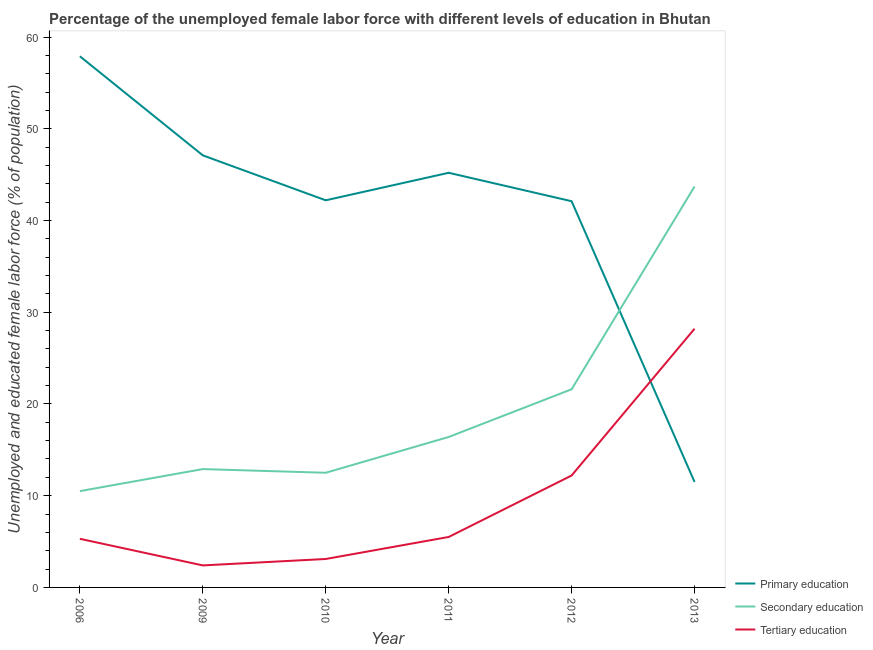Does the line corresponding to percentage of female labor force who received tertiary education intersect with the line corresponding to percentage of female labor force who received primary education?
Provide a short and direct response. Yes. Across all years, what is the maximum percentage of female labor force who received primary education?
Your response must be concise. 57.9. What is the total percentage of female labor force who received primary education in the graph?
Give a very brief answer. 246. What is the difference between the percentage of female labor force who received primary education in 2013 and the percentage of female labor force who received tertiary education in 2011?
Give a very brief answer. 6. What is the average percentage of female labor force who received primary education per year?
Provide a short and direct response. 41. In the year 2012, what is the difference between the percentage of female labor force who received tertiary education and percentage of female labor force who received secondary education?
Make the answer very short. -9.4. In how many years, is the percentage of female labor force who received tertiary education greater than 16 %?
Ensure brevity in your answer.  1. What is the ratio of the percentage of female labor force who received tertiary education in 2010 to that in 2012?
Your answer should be compact. 0.25. What is the difference between the highest and the second highest percentage of female labor force who received tertiary education?
Provide a succinct answer. 16. What is the difference between the highest and the lowest percentage of female labor force who received secondary education?
Give a very brief answer. 33.2. Is the sum of the percentage of female labor force who received tertiary education in 2006 and 2010 greater than the maximum percentage of female labor force who received primary education across all years?
Offer a terse response. No. Does the percentage of female labor force who received primary education monotonically increase over the years?
Provide a short and direct response. No. Is the percentage of female labor force who received primary education strictly greater than the percentage of female labor force who received tertiary education over the years?
Your response must be concise. No. Is the percentage of female labor force who received secondary education strictly less than the percentage of female labor force who received tertiary education over the years?
Make the answer very short. No. How many lines are there?
Keep it short and to the point. 3. How many years are there in the graph?
Your answer should be very brief. 6. Does the graph contain any zero values?
Your answer should be very brief. No. What is the title of the graph?
Your answer should be very brief. Percentage of the unemployed female labor force with different levels of education in Bhutan. What is the label or title of the Y-axis?
Your response must be concise. Unemployed and educated female labor force (% of population). What is the Unemployed and educated female labor force (% of population) of Primary education in 2006?
Your answer should be compact. 57.9. What is the Unemployed and educated female labor force (% of population) of Secondary education in 2006?
Provide a succinct answer. 10.5. What is the Unemployed and educated female labor force (% of population) in Tertiary education in 2006?
Provide a succinct answer. 5.3. What is the Unemployed and educated female labor force (% of population) in Primary education in 2009?
Provide a succinct answer. 47.1. What is the Unemployed and educated female labor force (% of population) of Secondary education in 2009?
Ensure brevity in your answer.  12.9. What is the Unemployed and educated female labor force (% of population) of Tertiary education in 2009?
Give a very brief answer. 2.4. What is the Unemployed and educated female labor force (% of population) of Primary education in 2010?
Make the answer very short. 42.2. What is the Unemployed and educated female labor force (% of population) of Tertiary education in 2010?
Provide a short and direct response. 3.1. What is the Unemployed and educated female labor force (% of population) of Primary education in 2011?
Provide a short and direct response. 45.2. What is the Unemployed and educated female labor force (% of population) of Secondary education in 2011?
Your answer should be very brief. 16.4. What is the Unemployed and educated female labor force (% of population) of Tertiary education in 2011?
Give a very brief answer. 5.5. What is the Unemployed and educated female labor force (% of population) in Primary education in 2012?
Offer a terse response. 42.1. What is the Unemployed and educated female labor force (% of population) of Secondary education in 2012?
Ensure brevity in your answer.  21.6. What is the Unemployed and educated female labor force (% of population) in Tertiary education in 2012?
Provide a short and direct response. 12.2. What is the Unemployed and educated female labor force (% of population) in Primary education in 2013?
Provide a short and direct response. 11.5. What is the Unemployed and educated female labor force (% of population) of Secondary education in 2013?
Provide a succinct answer. 43.7. What is the Unemployed and educated female labor force (% of population) in Tertiary education in 2013?
Make the answer very short. 28.2. Across all years, what is the maximum Unemployed and educated female labor force (% of population) in Primary education?
Ensure brevity in your answer.  57.9. Across all years, what is the maximum Unemployed and educated female labor force (% of population) in Secondary education?
Provide a short and direct response. 43.7. Across all years, what is the maximum Unemployed and educated female labor force (% of population) of Tertiary education?
Offer a very short reply. 28.2. Across all years, what is the minimum Unemployed and educated female labor force (% of population) in Primary education?
Your answer should be compact. 11.5. Across all years, what is the minimum Unemployed and educated female labor force (% of population) of Secondary education?
Your answer should be compact. 10.5. Across all years, what is the minimum Unemployed and educated female labor force (% of population) of Tertiary education?
Offer a terse response. 2.4. What is the total Unemployed and educated female labor force (% of population) of Primary education in the graph?
Make the answer very short. 246. What is the total Unemployed and educated female labor force (% of population) in Secondary education in the graph?
Ensure brevity in your answer.  117.6. What is the total Unemployed and educated female labor force (% of population) in Tertiary education in the graph?
Give a very brief answer. 56.7. What is the difference between the Unemployed and educated female labor force (% of population) of Secondary education in 2006 and that in 2009?
Offer a very short reply. -2.4. What is the difference between the Unemployed and educated female labor force (% of population) in Secondary education in 2006 and that in 2010?
Your response must be concise. -2. What is the difference between the Unemployed and educated female labor force (% of population) of Tertiary education in 2006 and that in 2010?
Your response must be concise. 2.2. What is the difference between the Unemployed and educated female labor force (% of population) in Tertiary education in 2006 and that in 2011?
Keep it short and to the point. -0.2. What is the difference between the Unemployed and educated female labor force (% of population) in Primary education in 2006 and that in 2013?
Provide a short and direct response. 46.4. What is the difference between the Unemployed and educated female labor force (% of population) in Secondary education in 2006 and that in 2013?
Your response must be concise. -33.2. What is the difference between the Unemployed and educated female labor force (% of population) of Tertiary education in 2006 and that in 2013?
Keep it short and to the point. -22.9. What is the difference between the Unemployed and educated female labor force (% of population) in Primary education in 2009 and that in 2010?
Your response must be concise. 4.9. What is the difference between the Unemployed and educated female labor force (% of population) of Primary education in 2009 and that in 2011?
Give a very brief answer. 1.9. What is the difference between the Unemployed and educated female labor force (% of population) of Secondary education in 2009 and that in 2011?
Offer a terse response. -3.5. What is the difference between the Unemployed and educated female labor force (% of population) of Tertiary education in 2009 and that in 2011?
Provide a short and direct response. -3.1. What is the difference between the Unemployed and educated female labor force (% of population) of Primary education in 2009 and that in 2013?
Keep it short and to the point. 35.6. What is the difference between the Unemployed and educated female labor force (% of population) in Secondary education in 2009 and that in 2013?
Ensure brevity in your answer.  -30.8. What is the difference between the Unemployed and educated female labor force (% of population) in Tertiary education in 2009 and that in 2013?
Offer a terse response. -25.8. What is the difference between the Unemployed and educated female labor force (% of population) in Secondary education in 2010 and that in 2011?
Keep it short and to the point. -3.9. What is the difference between the Unemployed and educated female labor force (% of population) in Tertiary education in 2010 and that in 2011?
Your answer should be very brief. -2.4. What is the difference between the Unemployed and educated female labor force (% of population) of Tertiary education in 2010 and that in 2012?
Offer a very short reply. -9.1. What is the difference between the Unemployed and educated female labor force (% of population) in Primary education in 2010 and that in 2013?
Provide a short and direct response. 30.7. What is the difference between the Unemployed and educated female labor force (% of population) of Secondary education in 2010 and that in 2013?
Your answer should be compact. -31.2. What is the difference between the Unemployed and educated female labor force (% of population) of Tertiary education in 2010 and that in 2013?
Keep it short and to the point. -25.1. What is the difference between the Unemployed and educated female labor force (% of population) in Primary education in 2011 and that in 2012?
Your answer should be very brief. 3.1. What is the difference between the Unemployed and educated female labor force (% of population) of Tertiary education in 2011 and that in 2012?
Provide a succinct answer. -6.7. What is the difference between the Unemployed and educated female labor force (% of population) of Primary education in 2011 and that in 2013?
Your answer should be very brief. 33.7. What is the difference between the Unemployed and educated female labor force (% of population) of Secondary education in 2011 and that in 2013?
Provide a short and direct response. -27.3. What is the difference between the Unemployed and educated female labor force (% of population) of Tertiary education in 2011 and that in 2013?
Give a very brief answer. -22.7. What is the difference between the Unemployed and educated female labor force (% of population) in Primary education in 2012 and that in 2013?
Ensure brevity in your answer.  30.6. What is the difference between the Unemployed and educated female labor force (% of population) of Secondary education in 2012 and that in 2013?
Offer a terse response. -22.1. What is the difference between the Unemployed and educated female labor force (% of population) of Tertiary education in 2012 and that in 2013?
Your answer should be very brief. -16. What is the difference between the Unemployed and educated female labor force (% of population) in Primary education in 2006 and the Unemployed and educated female labor force (% of population) in Secondary education in 2009?
Your answer should be compact. 45. What is the difference between the Unemployed and educated female labor force (% of population) of Primary education in 2006 and the Unemployed and educated female labor force (% of population) of Tertiary education in 2009?
Offer a terse response. 55.5. What is the difference between the Unemployed and educated female labor force (% of population) in Secondary education in 2006 and the Unemployed and educated female labor force (% of population) in Tertiary education in 2009?
Offer a terse response. 8.1. What is the difference between the Unemployed and educated female labor force (% of population) in Primary education in 2006 and the Unemployed and educated female labor force (% of population) in Secondary education in 2010?
Keep it short and to the point. 45.4. What is the difference between the Unemployed and educated female labor force (% of population) of Primary education in 2006 and the Unemployed and educated female labor force (% of population) of Tertiary education in 2010?
Keep it short and to the point. 54.8. What is the difference between the Unemployed and educated female labor force (% of population) in Secondary education in 2006 and the Unemployed and educated female labor force (% of population) in Tertiary education in 2010?
Offer a very short reply. 7.4. What is the difference between the Unemployed and educated female labor force (% of population) in Primary education in 2006 and the Unemployed and educated female labor force (% of population) in Secondary education in 2011?
Keep it short and to the point. 41.5. What is the difference between the Unemployed and educated female labor force (% of population) in Primary education in 2006 and the Unemployed and educated female labor force (% of population) in Tertiary education in 2011?
Offer a very short reply. 52.4. What is the difference between the Unemployed and educated female labor force (% of population) in Secondary education in 2006 and the Unemployed and educated female labor force (% of population) in Tertiary education in 2011?
Make the answer very short. 5. What is the difference between the Unemployed and educated female labor force (% of population) in Primary education in 2006 and the Unemployed and educated female labor force (% of population) in Secondary education in 2012?
Keep it short and to the point. 36.3. What is the difference between the Unemployed and educated female labor force (% of population) of Primary education in 2006 and the Unemployed and educated female labor force (% of population) of Tertiary education in 2012?
Offer a terse response. 45.7. What is the difference between the Unemployed and educated female labor force (% of population) of Primary education in 2006 and the Unemployed and educated female labor force (% of population) of Secondary education in 2013?
Provide a succinct answer. 14.2. What is the difference between the Unemployed and educated female labor force (% of population) of Primary education in 2006 and the Unemployed and educated female labor force (% of population) of Tertiary education in 2013?
Give a very brief answer. 29.7. What is the difference between the Unemployed and educated female labor force (% of population) of Secondary education in 2006 and the Unemployed and educated female labor force (% of population) of Tertiary education in 2013?
Offer a terse response. -17.7. What is the difference between the Unemployed and educated female labor force (% of population) in Primary education in 2009 and the Unemployed and educated female labor force (% of population) in Secondary education in 2010?
Your answer should be compact. 34.6. What is the difference between the Unemployed and educated female labor force (% of population) in Secondary education in 2009 and the Unemployed and educated female labor force (% of population) in Tertiary education in 2010?
Give a very brief answer. 9.8. What is the difference between the Unemployed and educated female labor force (% of population) of Primary education in 2009 and the Unemployed and educated female labor force (% of population) of Secondary education in 2011?
Provide a succinct answer. 30.7. What is the difference between the Unemployed and educated female labor force (% of population) of Primary education in 2009 and the Unemployed and educated female labor force (% of population) of Tertiary education in 2011?
Make the answer very short. 41.6. What is the difference between the Unemployed and educated female labor force (% of population) in Primary education in 2009 and the Unemployed and educated female labor force (% of population) in Secondary education in 2012?
Provide a short and direct response. 25.5. What is the difference between the Unemployed and educated female labor force (% of population) in Primary education in 2009 and the Unemployed and educated female labor force (% of population) in Tertiary education in 2012?
Your answer should be compact. 34.9. What is the difference between the Unemployed and educated female labor force (% of population) of Secondary education in 2009 and the Unemployed and educated female labor force (% of population) of Tertiary education in 2012?
Keep it short and to the point. 0.7. What is the difference between the Unemployed and educated female labor force (% of population) of Secondary education in 2009 and the Unemployed and educated female labor force (% of population) of Tertiary education in 2013?
Your answer should be very brief. -15.3. What is the difference between the Unemployed and educated female labor force (% of population) of Primary education in 2010 and the Unemployed and educated female labor force (% of population) of Secondary education in 2011?
Offer a terse response. 25.8. What is the difference between the Unemployed and educated female labor force (% of population) of Primary education in 2010 and the Unemployed and educated female labor force (% of population) of Tertiary education in 2011?
Make the answer very short. 36.7. What is the difference between the Unemployed and educated female labor force (% of population) in Primary education in 2010 and the Unemployed and educated female labor force (% of population) in Secondary education in 2012?
Provide a short and direct response. 20.6. What is the difference between the Unemployed and educated female labor force (% of population) of Primary education in 2010 and the Unemployed and educated female labor force (% of population) of Secondary education in 2013?
Offer a very short reply. -1.5. What is the difference between the Unemployed and educated female labor force (% of population) of Secondary education in 2010 and the Unemployed and educated female labor force (% of population) of Tertiary education in 2013?
Provide a short and direct response. -15.7. What is the difference between the Unemployed and educated female labor force (% of population) of Primary education in 2011 and the Unemployed and educated female labor force (% of population) of Secondary education in 2012?
Provide a short and direct response. 23.6. What is the difference between the Unemployed and educated female labor force (% of population) of Primary education in 2011 and the Unemployed and educated female labor force (% of population) of Secondary education in 2013?
Your response must be concise. 1.5. What is the difference between the Unemployed and educated female labor force (% of population) in Primary education in 2011 and the Unemployed and educated female labor force (% of population) in Tertiary education in 2013?
Provide a succinct answer. 17. What is the difference between the Unemployed and educated female labor force (% of population) of Secondary education in 2012 and the Unemployed and educated female labor force (% of population) of Tertiary education in 2013?
Provide a succinct answer. -6.6. What is the average Unemployed and educated female labor force (% of population) of Primary education per year?
Provide a short and direct response. 41. What is the average Unemployed and educated female labor force (% of population) in Secondary education per year?
Make the answer very short. 19.6. What is the average Unemployed and educated female labor force (% of population) in Tertiary education per year?
Your answer should be compact. 9.45. In the year 2006, what is the difference between the Unemployed and educated female labor force (% of population) in Primary education and Unemployed and educated female labor force (% of population) in Secondary education?
Your answer should be compact. 47.4. In the year 2006, what is the difference between the Unemployed and educated female labor force (% of population) in Primary education and Unemployed and educated female labor force (% of population) in Tertiary education?
Provide a succinct answer. 52.6. In the year 2006, what is the difference between the Unemployed and educated female labor force (% of population) of Secondary education and Unemployed and educated female labor force (% of population) of Tertiary education?
Provide a succinct answer. 5.2. In the year 2009, what is the difference between the Unemployed and educated female labor force (% of population) of Primary education and Unemployed and educated female labor force (% of population) of Secondary education?
Your answer should be very brief. 34.2. In the year 2009, what is the difference between the Unemployed and educated female labor force (% of population) of Primary education and Unemployed and educated female labor force (% of population) of Tertiary education?
Give a very brief answer. 44.7. In the year 2009, what is the difference between the Unemployed and educated female labor force (% of population) in Secondary education and Unemployed and educated female labor force (% of population) in Tertiary education?
Your answer should be very brief. 10.5. In the year 2010, what is the difference between the Unemployed and educated female labor force (% of population) of Primary education and Unemployed and educated female labor force (% of population) of Secondary education?
Make the answer very short. 29.7. In the year 2010, what is the difference between the Unemployed and educated female labor force (% of population) in Primary education and Unemployed and educated female labor force (% of population) in Tertiary education?
Your response must be concise. 39.1. In the year 2011, what is the difference between the Unemployed and educated female labor force (% of population) of Primary education and Unemployed and educated female labor force (% of population) of Secondary education?
Your answer should be compact. 28.8. In the year 2011, what is the difference between the Unemployed and educated female labor force (% of population) in Primary education and Unemployed and educated female labor force (% of population) in Tertiary education?
Your response must be concise. 39.7. In the year 2012, what is the difference between the Unemployed and educated female labor force (% of population) of Primary education and Unemployed and educated female labor force (% of population) of Secondary education?
Make the answer very short. 20.5. In the year 2012, what is the difference between the Unemployed and educated female labor force (% of population) of Primary education and Unemployed and educated female labor force (% of population) of Tertiary education?
Ensure brevity in your answer.  29.9. In the year 2012, what is the difference between the Unemployed and educated female labor force (% of population) in Secondary education and Unemployed and educated female labor force (% of population) in Tertiary education?
Give a very brief answer. 9.4. In the year 2013, what is the difference between the Unemployed and educated female labor force (% of population) in Primary education and Unemployed and educated female labor force (% of population) in Secondary education?
Provide a short and direct response. -32.2. In the year 2013, what is the difference between the Unemployed and educated female labor force (% of population) of Primary education and Unemployed and educated female labor force (% of population) of Tertiary education?
Give a very brief answer. -16.7. What is the ratio of the Unemployed and educated female labor force (% of population) in Primary education in 2006 to that in 2009?
Make the answer very short. 1.23. What is the ratio of the Unemployed and educated female labor force (% of population) in Secondary education in 2006 to that in 2009?
Offer a very short reply. 0.81. What is the ratio of the Unemployed and educated female labor force (% of population) of Tertiary education in 2006 to that in 2009?
Keep it short and to the point. 2.21. What is the ratio of the Unemployed and educated female labor force (% of population) in Primary education in 2006 to that in 2010?
Offer a very short reply. 1.37. What is the ratio of the Unemployed and educated female labor force (% of population) in Secondary education in 2006 to that in 2010?
Offer a very short reply. 0.84. What is the ratio of the Unemployed and educated female labor force (% of population) of Tertiary education in 2006 to that in 2010?
Ensure brevity in your answer.  1.71. What is the ratio of the Unemployed and educated female labor force (% of population) in Primary education in 2006 to that in 2011?
Ensure brevity in your answer.  1.28. What is the ratio of the Unemployed and educated female labor force (% of population) of Secondary education in 2006 to that in 2011?
Offer a very short reply. 0.64. What is the ratio of the Unemployed and educated female labor force (% of population) of Tertiary education in 2006 to that in 2011?
Ensure brevity in your answer.  0.96. What is the ratio of the Unemployed and educated female labor force (% of population) in Primary education in 2006 to that in 2012?
Offer a very short reply. 1.38. What is the ratio of the Unemployed and educated female labor force (% of population) in Secondary education in 2006 to that in 2012?
Offer a very short reply. 0.49. What is the ratio of the Unemployed and educated female labor force (% of population) in Tertiary education in 2006 to that in 2012?
Give a very brief answer. 0.43. What is the ratio of the Unemployed and educated female labor force (% of population) of Primary education in 2006 to that in 2013?
Make the answer very short. 5.03. What is the ratio of the Unemployed and educated female labor force (% of population) of Secondary education in 2006 to that in 2013?
Your answer should be compact. 0.24. What is the ratio of the Unemployed and educated female labor force (% of population) in Tertiary education in 2006 to that in 2013?
Offer a very short reply. 0.19. What is the ratio of the Unemployed and educated female labor force (% of population) of Primary education in 2009 to that in 2010?
Your answer should be very brief. 1.12. What is the ratio of the Unemployed and educated female labor force (% of population) of Secondary education in 2009 to that in 2010?
Offer a very short reply. 1.03. What is the ratio of the Unemployed and educated female labor force (% of population) in Tertiary education in 2009 to that in 2010?
Ensure brevity in your answer.  0.77. What is the ratio of the Unemployed and educated female labor force (% of population) in Primary education in 2009 to that in 2011?
Provide a succinct answer. 1.04. What is the ratio of the Unemployed and educated female labor force (% of population) of Secondary education in 2009 to that in 2011?
Keep it short and to the point. 0.79. What is the ratio of the Unemployed and educated female labor force (% of population) in Tertiary education in 2009 to that in 2011?
Offer a very short reply. 0.44. What is the ratio of the Unemployed and educated female labor force (% of population) of Primary education in 2009 to that in 2012?
Your response must be concise. 1.12. What is the ratio of the Unemployed and educated female labor force (% of population) of Secondary education in 2009 to that in 2012?
Ensure brevity in your answer.  0.6. What is the ratio of the Unemployed and educated female labor force (% of population) in Tertiary education in 2009 to that in 2012?
Your answer should be very brief. 0.2. What is the ratio of the Unemployed and educated female labor force (% of population) in Primary education in 2009 to that in 2013?
Keep it short and to the point. 4.1. What is the ratio of the Unemployed and educated female labor force (% of population) of Secondary education in 2009 to that in 2013?
Your answer should be very brief. 0.3. What is the ratio of the Unemployed and educated female labor force (% of population) in Tertiary education in 2009 to that in 2013?
Make the answer very short. 0.09. What is the ratio of the Unemployed and educated female labor force (% of population) of Primary education in 2010 to that in 2011?
Your answer should be compact. 0.93. What is the ratio of the Unemployed and educated female labor force (% of population) of Secondary education in 2010 to that in 2011?
Keep it short and to the point. 0.76. What is the ratio of the Unemployed and educated female labor force (% of population) in Tertiary education in 2010 to that in 2011?
Make the answer very short. 0.56. What is the ratio of the Unemployed and educated female labor force (% of population) in Secondary education in 2010 to that in 2012?
Offer a terse response. 0.58. What is the ratio of the Unemployed and educated female labor force (% of population) in Tertiary education in 2010 to that in 2012?
Offer a terse response. 0.25. What is the ratio of the Unemployed and educated female labor force (% of population) of Primary education in 2010 to that in 2013?
Your answer should be very brief. 3.67. What is the ratio of the Unemployed and educated female labor force (% of population) of Secondary education in 2010 to that in 2013?
Make the answer very short. 0.29. What is the ratio of the Unemployed and educated female labor force (% of population) in Tertiary education in 2010 to that in 2013?
Give a very brief answer. 0.11. What is the ratio of the Unemployed and educated female labor force (% of population) of Primary education in 2011 to that in 2012?
Offer a terse response. 1.07. What is the ratio of the Unemployed and educated female labor force (% of population) in Secondary education in 2011 to that in 2012?
Your response must be concise. 0.76. What is the ratio of the Unemployed and educated female labor force (% of population) of Tertiary education in 2011 to that in 2012?
Offer a terse response. 0.45. What is the ratio of the Unemployed and educated female labor force (% of population) in Primary education in 2011 to that in 2013?
Offer a very short reply. 3.93. What is the ratio of the Unemployed and educated female labor force (% of population) of Secondary education in 2011 to that in 2013?
Provide a succinct answer. 0.38. What is the ratio of the Unemployed and educated female labor force (% of population) in Tertiary education in 2011 to that in 2013?
Give a very brief answer. 0.2. What is the ratio of the Unemployed and educated female labor force (% of population) of Primary education in 2012 to that in 2013?
Provide a succinct answer. 3.66. What is the ratio of the Unemployed and educated female labor force (% of population) of Secondary education in 2012 to that in 2013?
Ensure brevity in your answer.  0.49. What is the ratio of the Unemployed and educated female labor force (% of population) in Tertiary education in 2012 to that in 2013?
Ensure brevity in your answer.  0.43. What is the difference between the highest and the second highest Unemployed and educated female labor force (% of population) of Secondary education?
Ensure brevity in your answer.  22.1. What is the difference between the highest and the lowest Unemployed and educated female labor force (% of population) of Primary education?
Your response must be concise. 46.4. What is the difference between the highest and the lowest Unemployed and educated female labor force (% of population) in Secondary education?
Your answer should be very brief. 33.2. What is the difference between the highest and the lowest Unemployed and educated female labor force (% of population) of Tertiary education?
Your answer should be very brief. 25.8. 